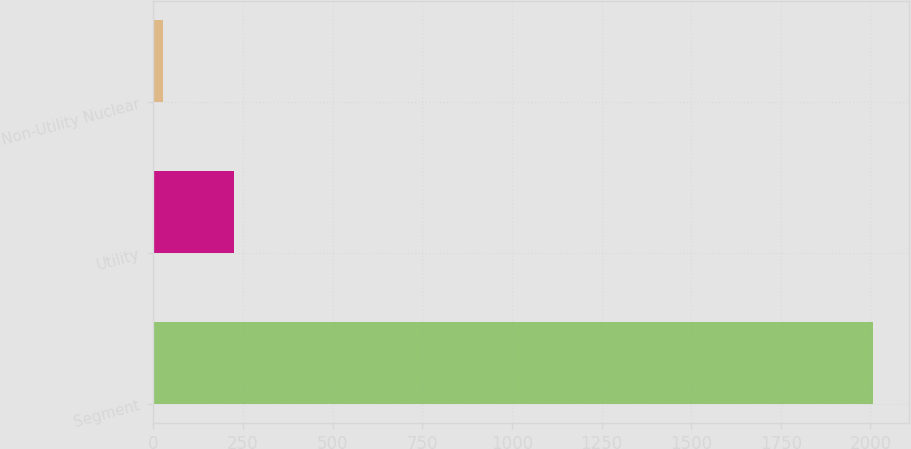<chart> <loc_0><loc_0><loc_500><loc_500><bar_chart><fcel>Segment<fcel>Utility<fcel>Non-Utility Nuclear<nl><fcel>2006<fcel>224.9<fcel>27<nl></chart> 